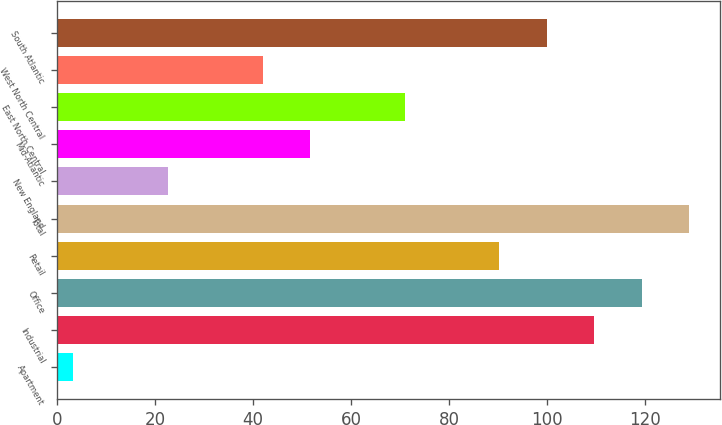Convert chart. <chart><loc_0><loc_0><loc_500><loc_500><bar_chart><fcel>Apartment<fcel>Industrial<fcel>Office<fcel>Retail<fcel>Total<fcel>New England<fcel>Mid-Atlantic<fcel>East North Central<fcel>West North Central<fcel>South Atlantic<nl><fcel>3.3<fcel>109.67<fcel>119.34<fcel>90.33<fcel>129.01<fcel>22.64<fcel>51.65<fcel>70.99<fcel>41.98<fcel>100<nl></chart> 